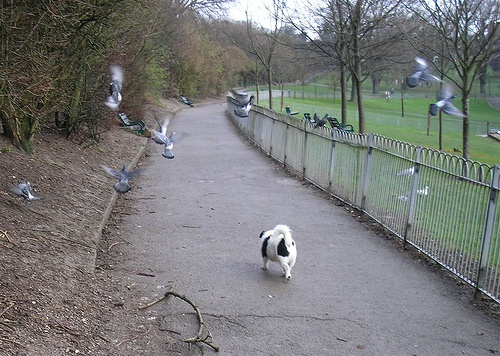Describe the objects in this image and their specific colors. I can see dog in black, white, darkgray, and gray tones, bird in black, gray, darkgray, and olive tones, bird in black, gray, and darkgray tones, bird in black, gray, and darkgray tones, and bird in black, darkgray, gray, and lavender tones in this image. 